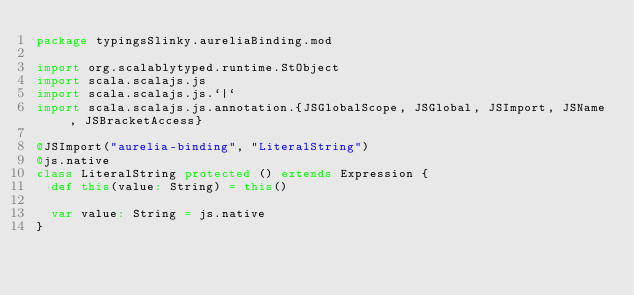Convert code to text. <code><loc_0><loc_0><loc_500><loc_500><_Scala_>package typingsSlinky.aureliaBinding.mod

import org.scalablytyped.runtime.StObject
import scala.scalajs.js
import scala.scalajs.js.`|`
import scala.scalajs.js.annotation.{JSGlobalScope, JSGlobal, JSImport, JSName, JSBracketAccess}

@JSImport("aurelia-binding", "LiteralString")
@js.native
class LiteralString protected () extends Expression {
  def this(value: String) = this()
  
  var value: String = js.native
}
</code> 